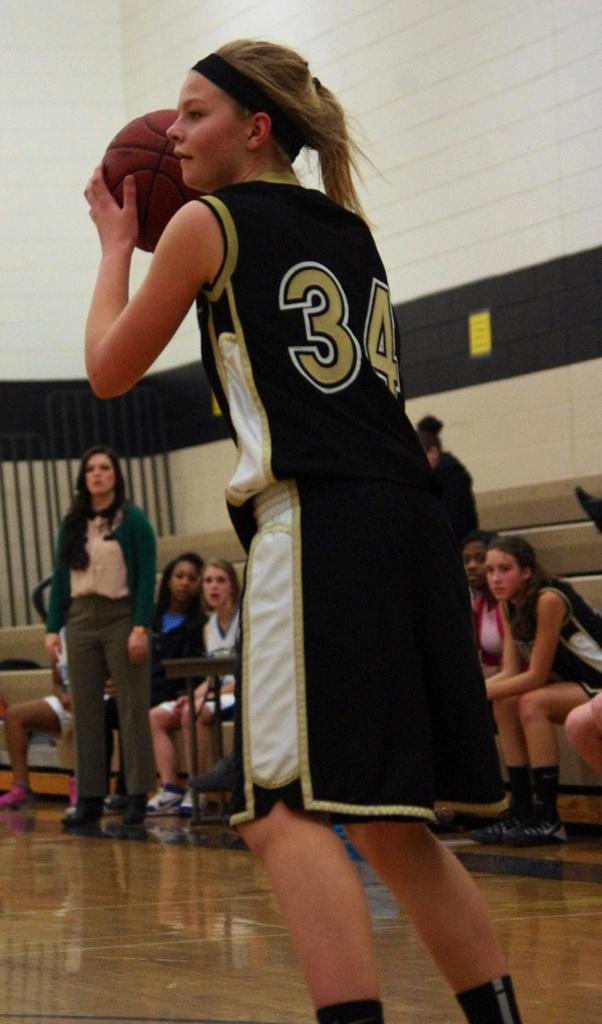Provide a one-sentence caption for the provided image. Number 34 has the ball as her teammates look on. 